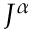<formula> <loc_0><loc_0><loc_500><loc_500>J ^ { \alpha }</formula> 